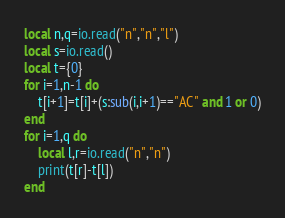<code> <loc_0><loc_0><loc_500><loc_500><_Lua_>local n,q=io.read("n","n","l")
local s=io.read()
local t={0}
for i=1,n-1 do
    t[i+1]=t[i]+(s:sub(i,i+1)=="AC" and 1 or 0)
end
for i=1,q do
    local l,r=io.read("n","n")
    print(t[r]-t[l])
end</code> 